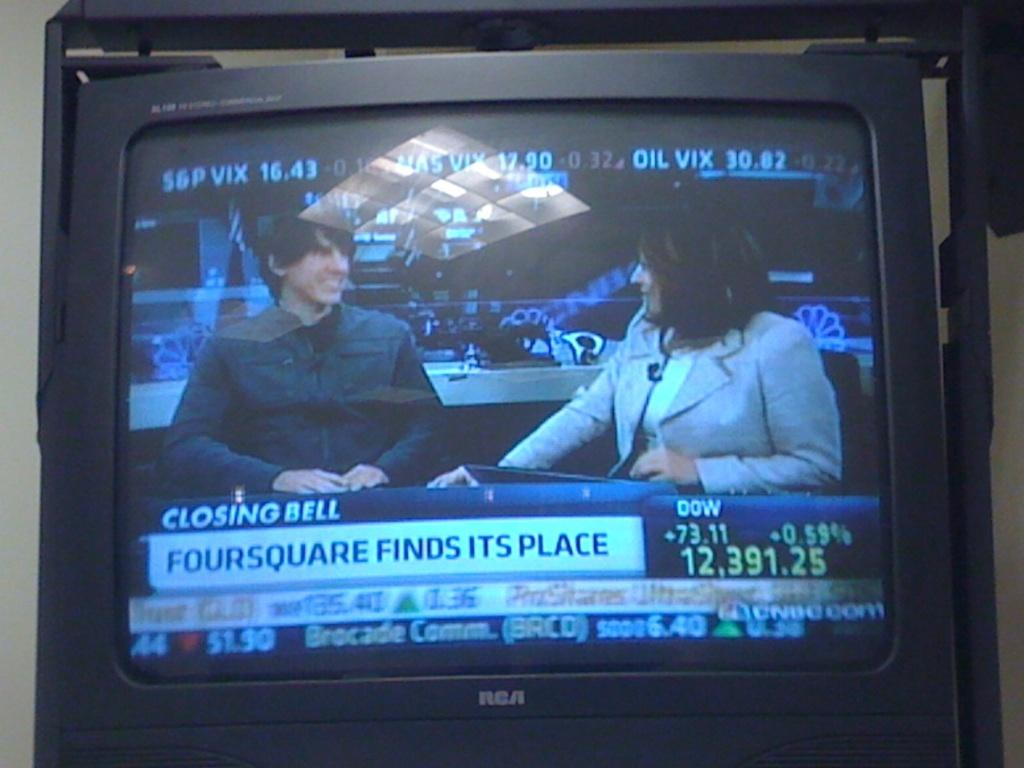<image>
Write a terse but informative summary of the picture. A television is showing something about the closing bell at the stock market. 